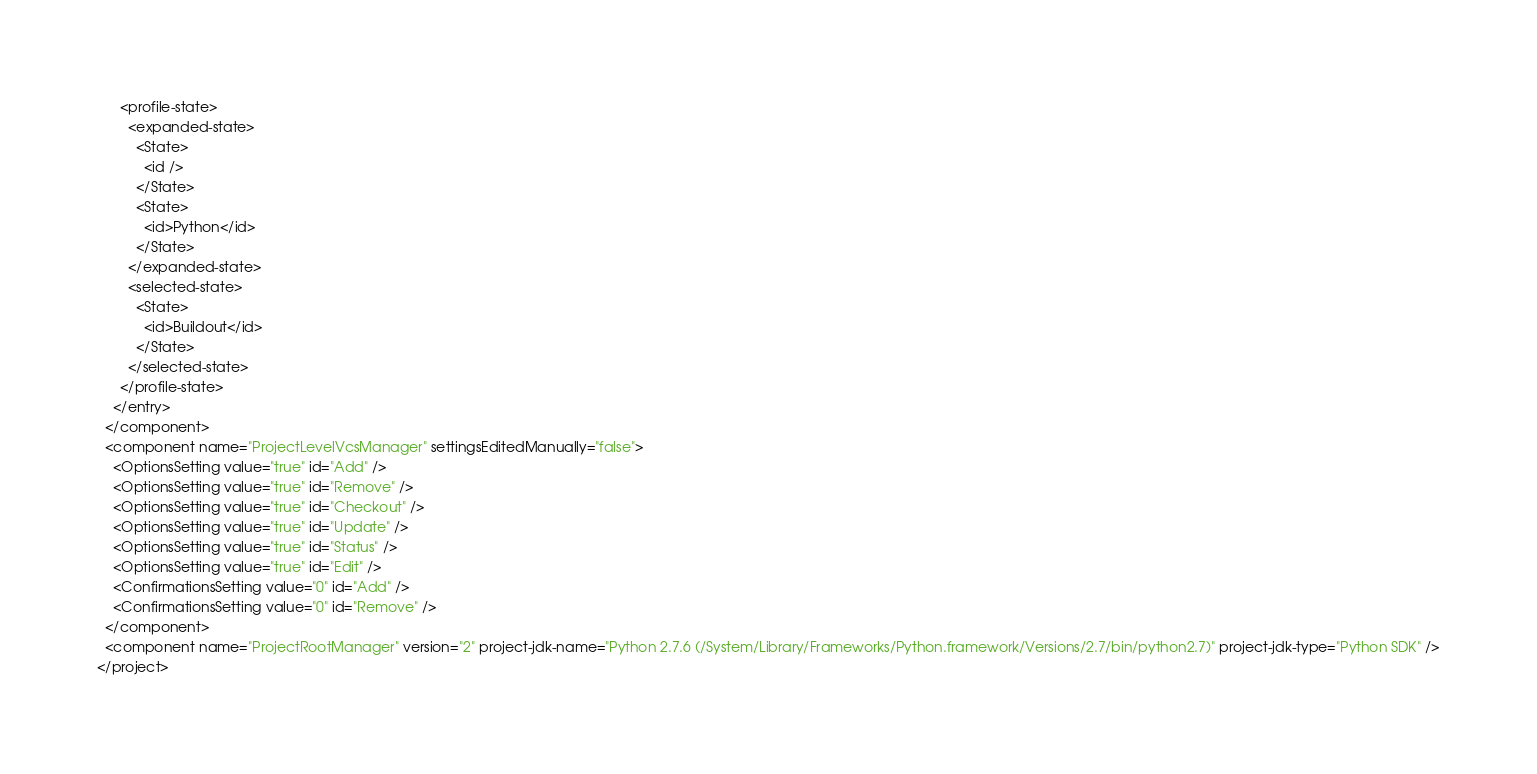Convert code to text. <code><loc_0><loc_0><loc_500><loc_500><_XML_>      <profile-state>
        <expanded-state>
          <State>
            <id />
          </State>
          <State>
            <id>Python</id>
          </State>
        </expanded-state>
        <selected-state>
          <State>
            <id>Buildout</id>
          </State>
        </selected-state>
      </profile-state>
    </entry>
  </component>
  <component name="ProjectLevelVcsManager" settingsEditedManually="false">
    <OptionsSetting value="true" id="Add" />
    <OptionsSetting value="true" id="Remove" />
    <OptionsSetting value="true" id="Checkout" />
    <OptionsSetting value="true" id="Update" />
    <OptionsSetting value="true" id="Status" />
    <OptionsSetting value="true" id="Edit" />
    <ConfirmationsSetting value="0" id="Add" />
    <ConfirmationsSetting value="0" id="Remove" />
  </component>
  <component name="ProjectRootManager" version="2" project-jdk-name="Python 2.7.6 (/System/Library/Frameworks/Python.framework/Versions/2.7/bin/python2.7)" project-jdk-type="Python SDK" />
</project></code> 